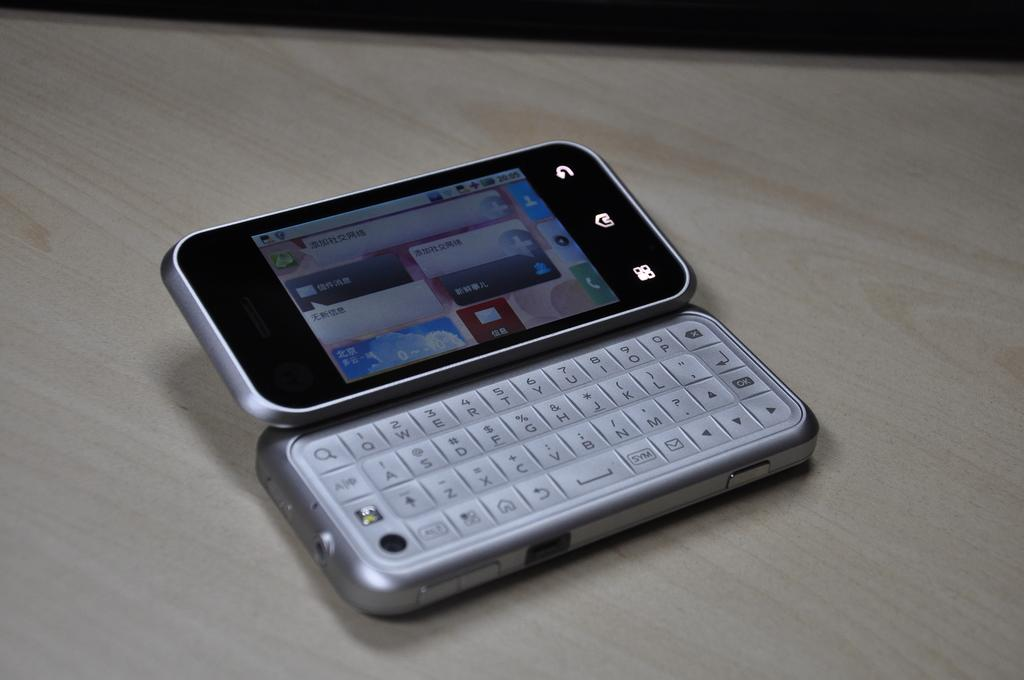What electronic device is visible in the image? There is a mobile phone in the image. What features are present on the mobile phone? The mobile phone has a keypad and a screen. What type of surface is the mobile phone placed on? The mobile phone is placed on a wooden surface. Can you see any cows grazing near the mobile phone in the image? No, there are no cows present in the image. 